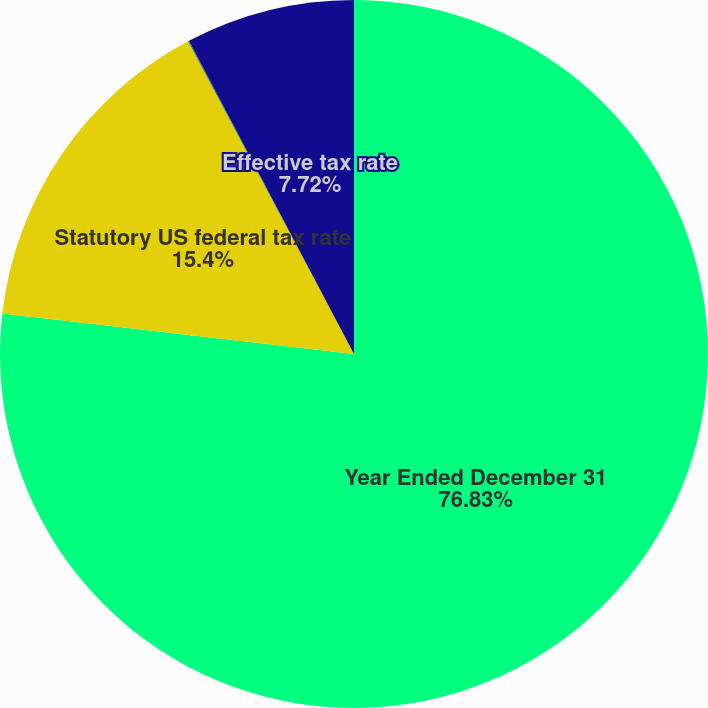<chart> <loc_0><loc_0><loc_500><loc_500><pie_chart><fcel>Year Ended December 31<fcel>Statutory US federal tax rate<fcel>State and local income taxes -<fcel>Effective tax rate<nl><fcel>76.83%<fcel>15.4%<fcel>0.05%<fcel>7.72%<nl></chart> 